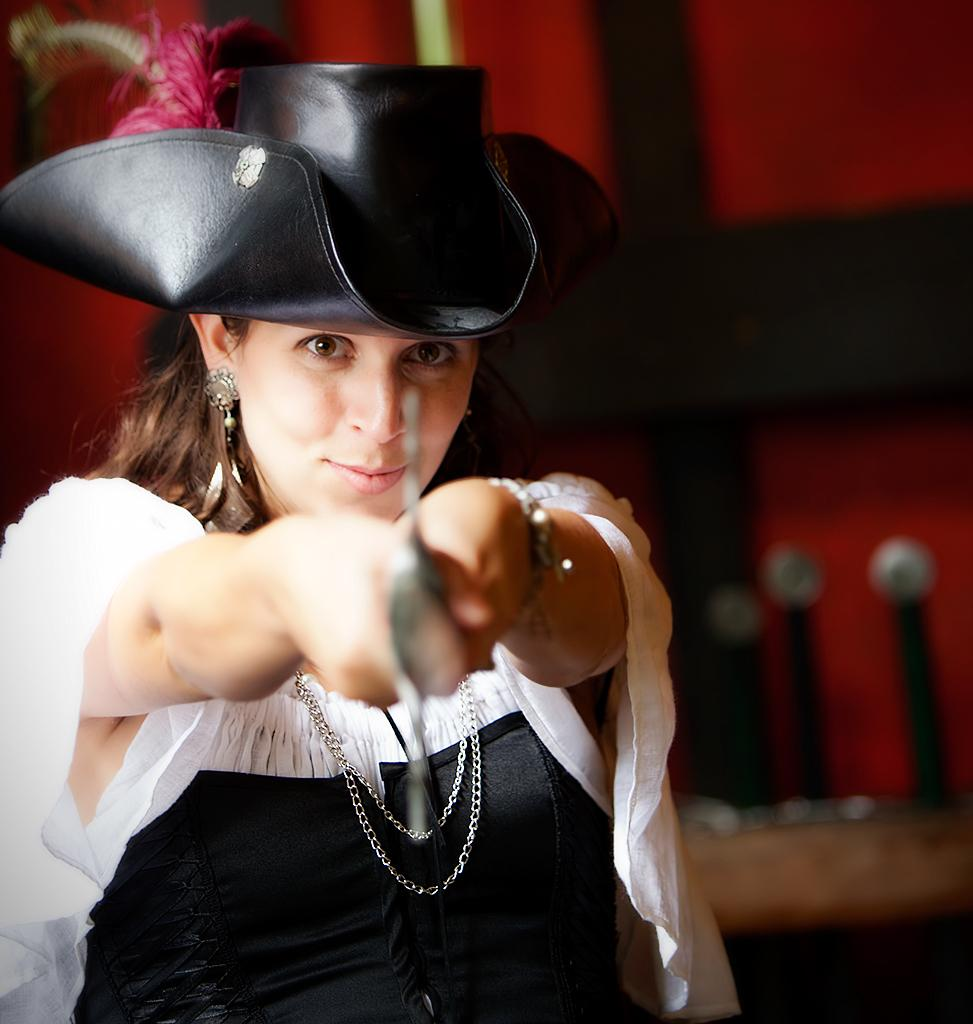What can be seen in the image? There is a person in the image. Can you describe the person's attire? The person is wearing a cap. What is the person holding in the image? The person is holding an object. What type of star can be seen in the image? There is no star present in the image. Is there a hose visible in the image? There is no hose present in the image. 